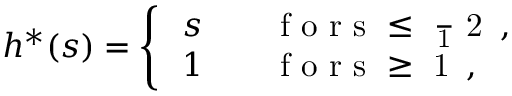Convert formula to latex. <formula><loc_0><loc_0><loc_500><loc_500>h ^ { \ast } ( s ) = \left \{ \begin{array} { l l } { \, s } & { \quad f o r s \leq \frac { 1 } { 2 } \, , } \\ { \, 1 } & { \quad f o r s \geq 1 \, , } \end{array}</formula> 